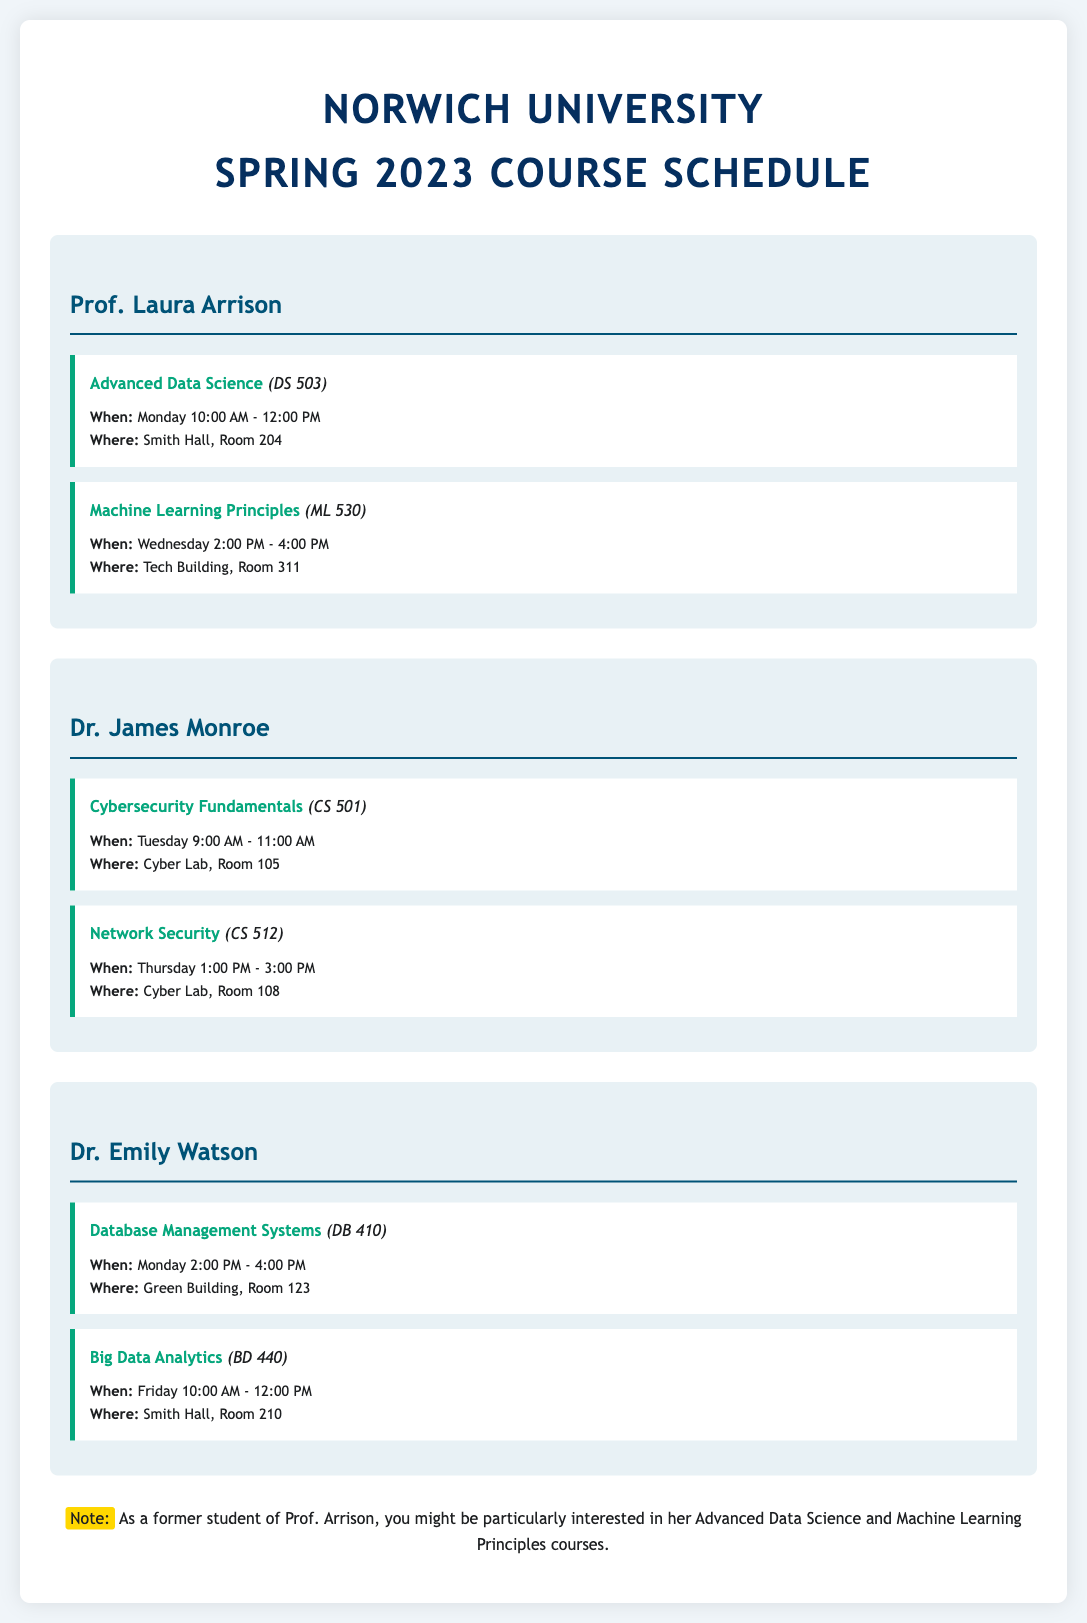What is the title of the document? The title of the document is indicated at the top and refers to the course schedule for the specific semester.
Answer: Norwich University Spring 2023 Course Schedule Who teaches the course "Advanced Data Science"? The instructor for the course "Advanced Data Science" is mentioned directly in the section corresponding to the course.
Answer: Prof. Laura Arrison When is "Machine Learning Principles" scheduled? The course schedule specifies the day and time for "Machine Learning Principles" under the corresponding instructor.
Answer: Wednesday 2:00 PM - 4:00 PM What room is "Big Data Analytics" held in? The location for "Big Data Analytics" is listed in the details of that course.
Answer: Smith Hall, Room 210 Which course is taught by Dr. Emily Watson on Monday? The courses listed under Dr. Emily Watson have specific days mentioned next to their titles, one of which is on Monday.
Answer: Database Management Systems What is the common venue for Prof. Laura Arrison's courses? Looking through the details, the venues for her courses can be located based on the provided information.
Answer: Smith Hall, Room 204 and Tech Building, Room 311 What color is used for the course name emphasis in the document? The course names are highlighted in a specific color according to the CSS styles declared in the code.
Answer: #06a77d How many courses does Dr. James Monroe teach? By counting the course entries listed under Dr. James Monroe, the total number can be easily determined.
Answer: 2 